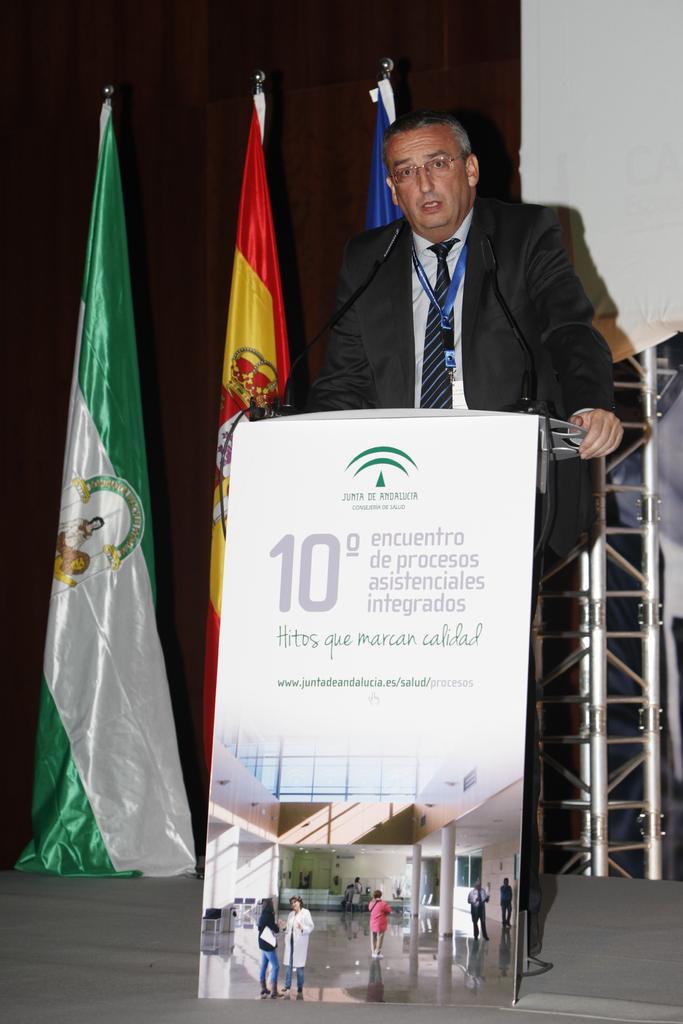Could you give a brief overview of what you see in this image? A man is standing, this is microphone and flags, this is poster. 